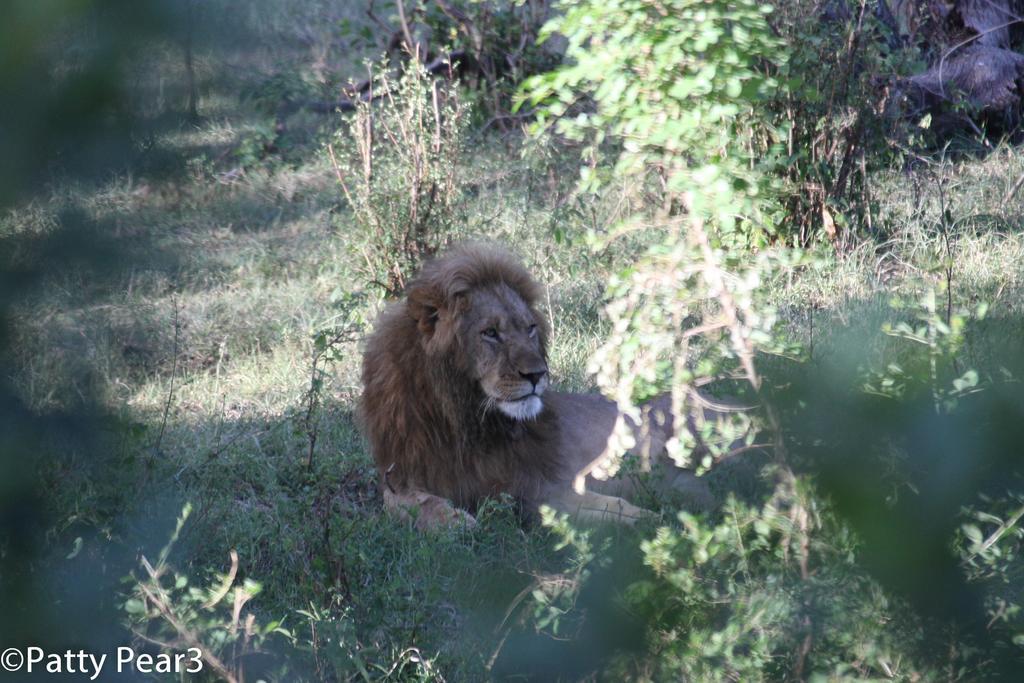Can you describe this image briefly? This image is clicked outside. There are plants in this image. There is a lion in the middle. There is grass in this image. 